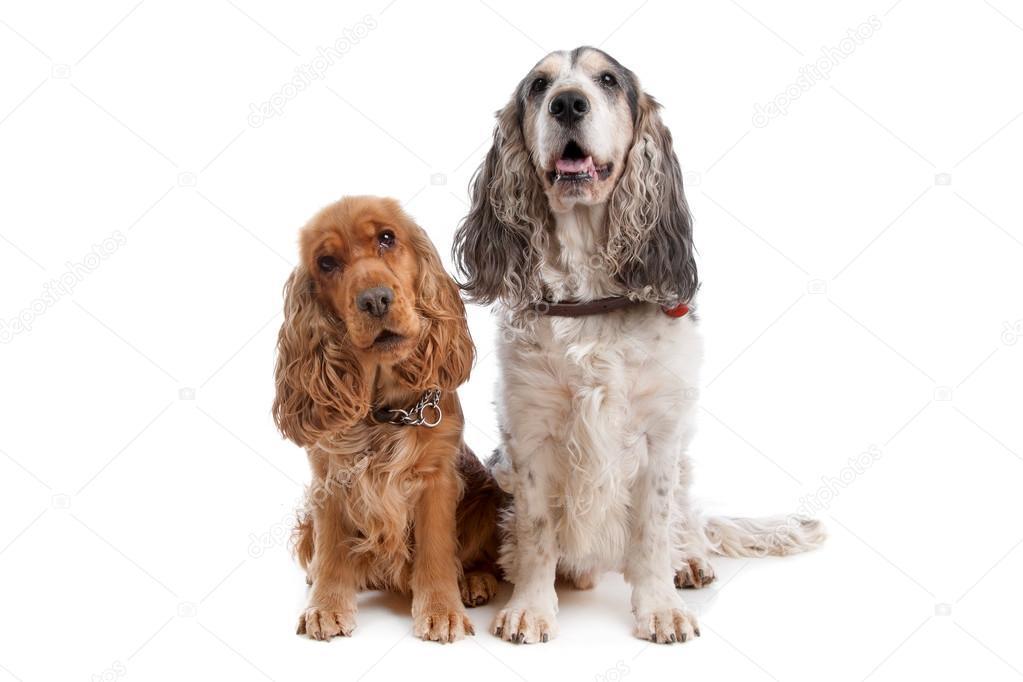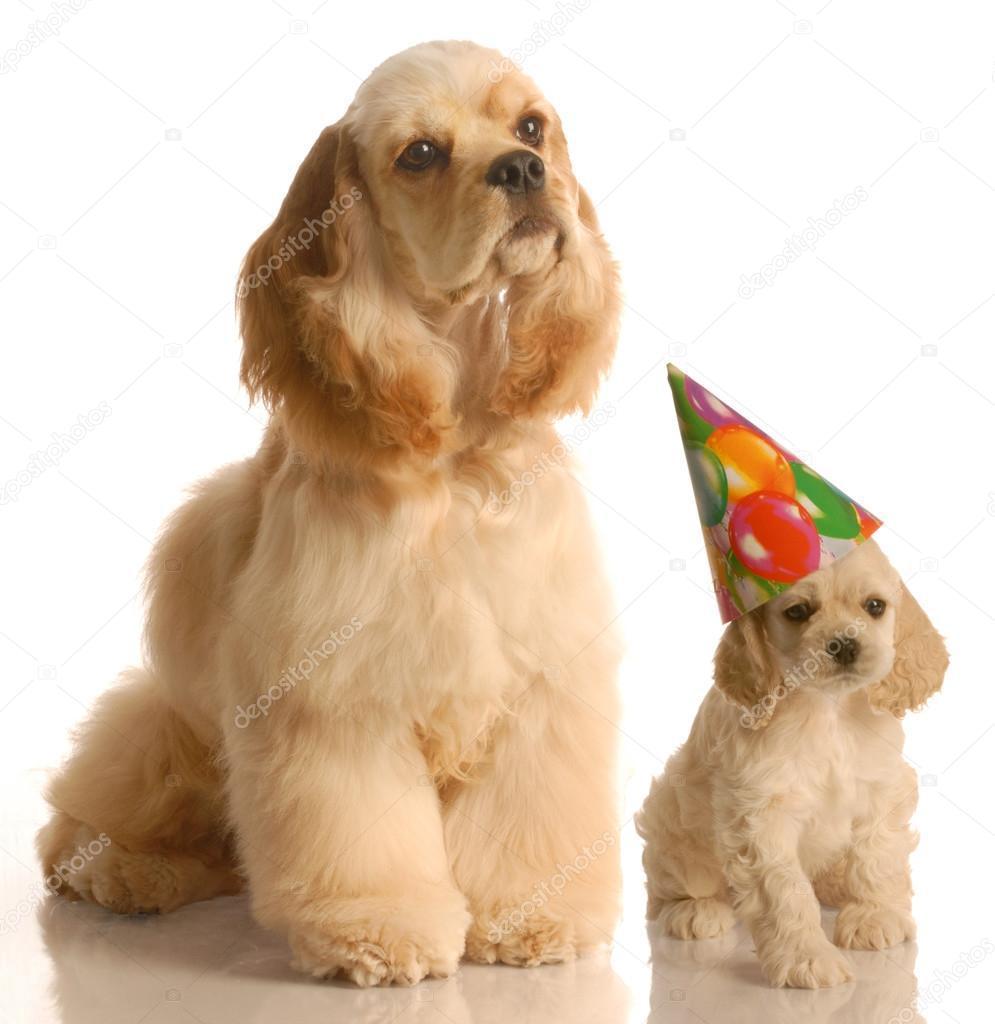The first image is the image on the left, the second image is the image on the right. Examine the images to the left and right. Is the description "there are 3 dogs in the image pair" accurate? Answer yes or no. No. The first image is the image on the left, the second image is the image on the right. Given the left and right images, does the statement "There are a total of 4 dogs present." hold true? Answer yes or no. Yes. 